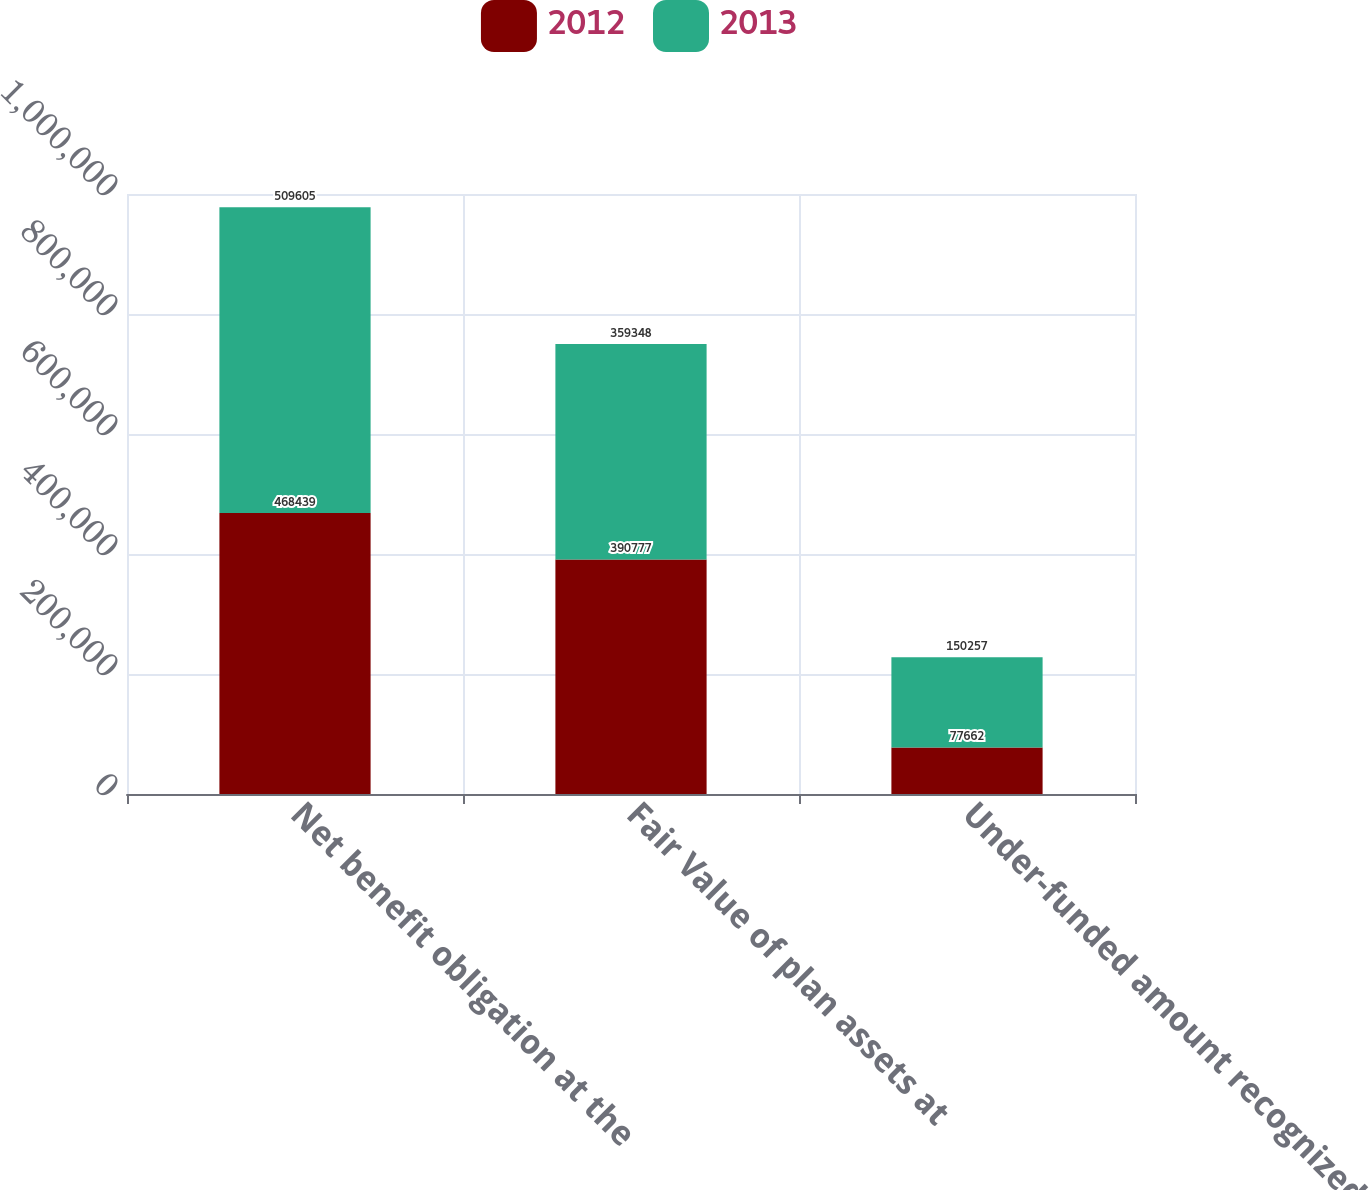Convert chart. <chart><loc_0><loc_0><loc_500><loc_500><stacked_bar_chart><ecel><fcel>Net benefit obligation at the<fcel>Fair Value of plan assets at<fcel>Under-funded amount recognized<nl><fcel>2012<fcel>468439<fcel>390777<fcel>77662<nl><fcel>2013<fcel>509605<fcel>359348<fcel>150257<nl></chart> 